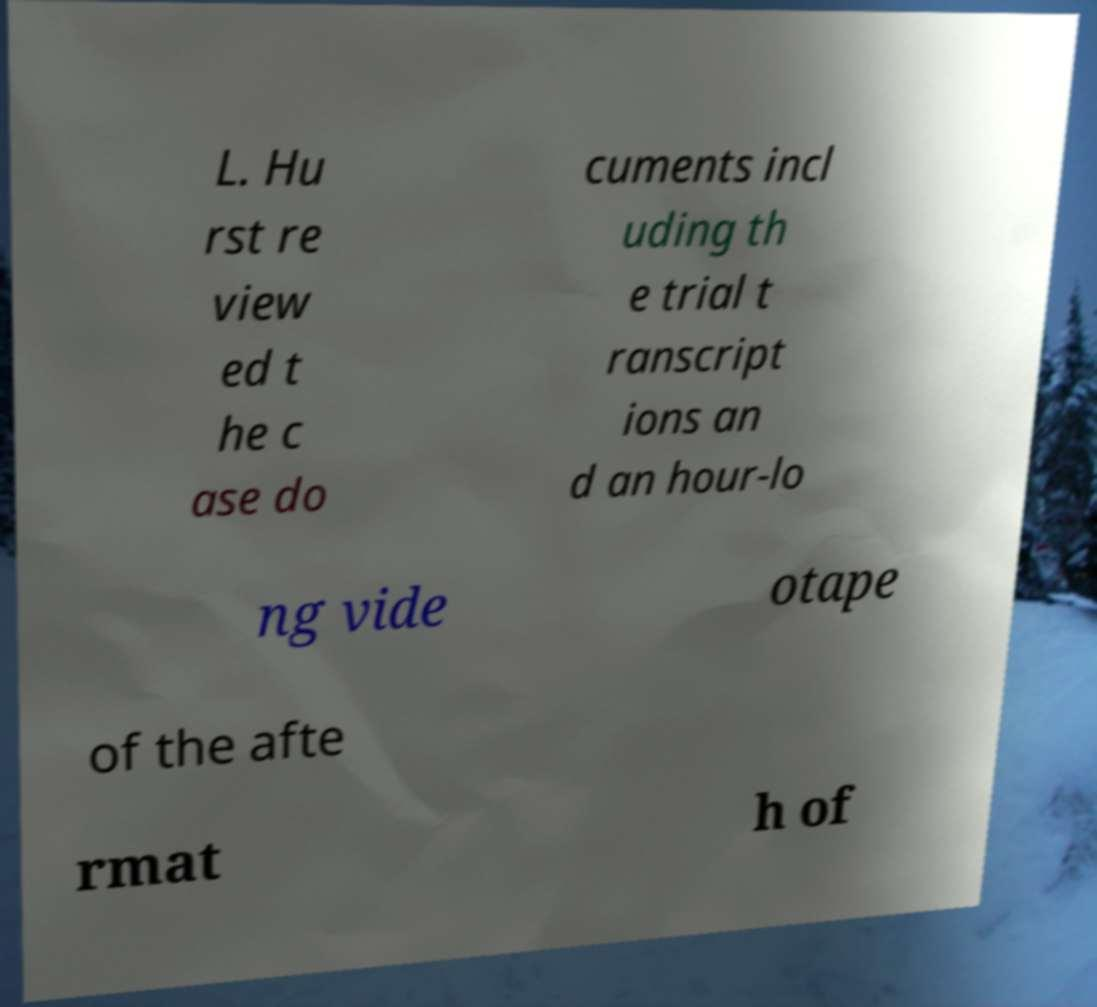I need the written content from this picture converted into text. Can you do that? L. Hu rst re view ed t he c ase do cuments incl uding th e trial t ranscript ions an d an hour-lo ng vide otape of the afte rmat h of 